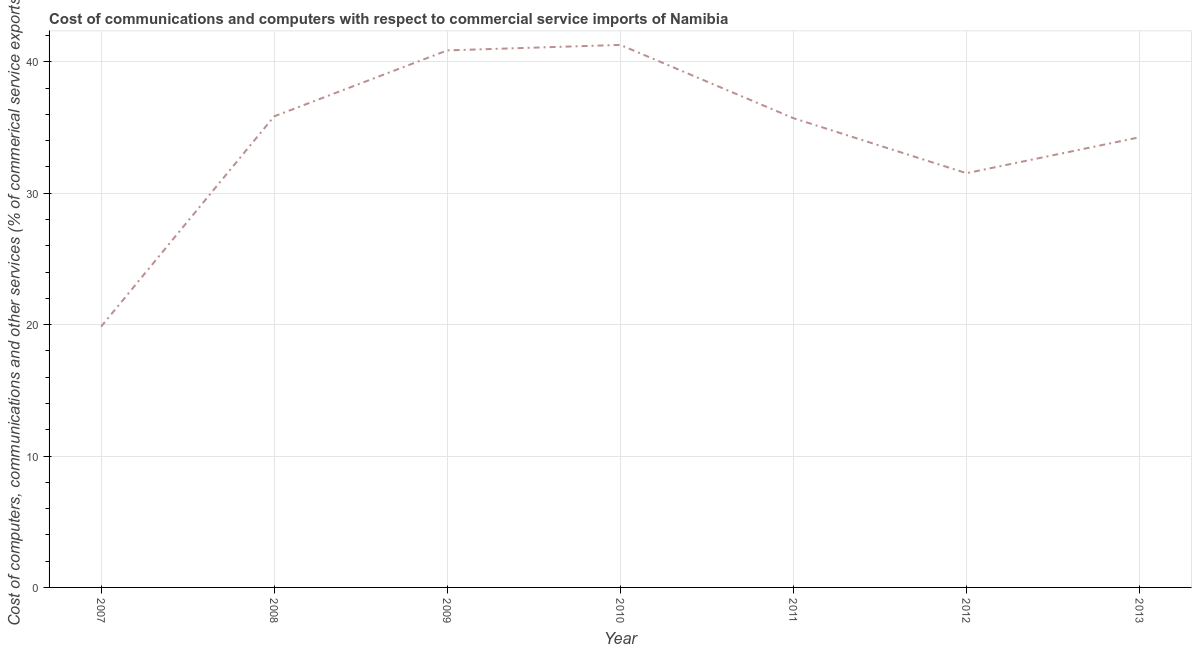What is the  computer and other services in 2013?
Offer a terse response. 34.26. Across all years, what is the maximum  computer and other services?
Provide a succinct answer. 41.28. Across all years, what is the minimum cost of communications?
Your response must be concise. 19.84. In which year was the cost of communications maximum?
Provide a succinct answer. 2010. What is the sum of the cost of communications?
Provide a short and direct response. 239.32. What is the difference between the  computer and other services in 2007 and 2008?
Keep it short and to the point. -16. What is the average cost of communications per year?
Provide a short and direct response. 34.19. What is the median  computer and other services?
Your answer should be compact. 35.71. In how many years, is the  computer and other services greater than 4 %?
Your response must be concise. 7. What is the ratio of the  computer and other services in 2012 to that in 2013?
Provide a short and direct response. 0.92. Is the difference between the cost of communications in 2008 and 2010 greater than the difference between any two years?
Your response must be concise. No. What is the difference between the highest and the second highest cost of communications?
Your response must be concise. 0.42. Is the sum of the cost of communications in 2010 and 2011 greater than the maximum cost of communications across all years?
Offer a terse response. Yes. What is the difference between the highest and the lowest cost of communications?
Provide a succinct answer. 21.44. Does the cost of communications monotonically increase over the years?
Your response must be concise. No. What is the difference between two consecutive major ticks on the Y-axis?
Make the answer very short. 10. Are the values on the major ticks of Y-axis written in scientific E-notation?
Keep it short and to the point. No. Does the graph contain any zero values?
Ensure brevity in your answer.  No. Does the graph contain grids?
Provide a succinct answer. Yes. What is the title of the graph?
Make the answer very short. Cost of communications and computers with respect to commercial service imports of Namibia. What is the label or title of the Y-axis?
Make the answer very short. Cost of computers, communications and other services (% of commerical service exports). What is the Cost of computers, communications and other services (% of commerical service exports) of 2007?
Provide a short and direct response. 19.84. What is the Cost of computers, communications and other services (% of commerical service exports) in 2008?
Make the answer very short. 35.85. What is the Cost of computers, communications and other services (% of commerical service exports) in 2009?
Offer a terse response. 40.87. What is the Cost of computers, communications and other services (% of commerical service exports) of 2010?
Offer a very short reply. 41.28. What is the Cost of computers, communications and other services (% of commerical service exports) of 2011?
Ensure brevity in your answer.  35.71. What is the Cost of computers, communications and other services (% of commerical service exports) of 2012?
Your answer should be very brief. 31.52. What is the Cost of computers, communications and other services (% of commerical service exports) of 2013?
Keep it short and to the point. 34.26. What is the difference between the Cost of computers, communications and other services (% of commerical service exports) in 2007 and 2008?
Your answer should be very brief. -16. What is the difference between the Cost of computers, communications and other services (% of commerical service exports) in 2007 and 2009?
Provide a succinct answer. -21.02. What is the difference between the Cost of computers, communications and other services (% of commerical service exports) in 2007 and 2010?
Make the answer very short. -21.44. What is the difference between the Cost of computers, communications and other services (% of commerical service exports) in 2007 and 2011?
Provide a succinct answer. -15.86. What is the difference between the Cost of computers, communications and other services (% of commerical service exports) in 2007 and 2012?
Your response must be concise. -11.68. What is the difference between the Cost of computers, communications and other services (% of commerical service exports) in 2007 and 2013?
Ensure brevity in your answer.  -14.41. What is the difference between the Cost of computers, communications and other services (% of commerical service exports) in 2008 and 2009?
Provide a short and direct response. -5.02. What is the difference between the Cost of computers, communications and other services (% of commerical service exports) in 2008 and 2010?
Your answer should be compact. -5.44. What is the difference between the Cost of computers, communications and other services (% of commerical service exports) in 2008 and 2011?
Offer a very short reply. 0.14. What is the difference between the Cost of computers, communications and other services (% of commerical service exports) in 2008 and 2012?
Offer a terse response. 4.33. What is the difference between the Cost of computers, communications and other services (% of commerical service exports) in 2008 and 2013?
Ensure brevity in your answer.  1.59. What is the difference between the Cost of computers, communications and other services (% of commerical service exports) in 2009 and 2010?
Offer a very short reply. -0.42. What is the difference between the Cost of computers, communications and other services (% of commerical service exports) in 2009 and 2011?
Offer a terse response. 5.16. What is the difference between the Cost of computers, communications and other services (% of commerical service exports) in 2009 and 2012?
Keep it short and to the point. 9.35. What is the difference between the Cost of computers, communications and other services (% of commerical service exports) in 2009 and 2013?
Keep it short and to the point. 6.61. What is the difference between the Cost of computers, communications and other services (% of commerical service exports) in 2010 and 2011?
Your answer should be compact. 5.57. What is the difference between the Cost of computers, communications and other services (% of commerical service exports) in 2010 and 2012?
Offer a very short reply. 9.76. What is the difference between the Cost of computers, communications and other services (% of commerical service exports) in 2010 and 2013?
Make the answer very short. 7.03. What is the difference between the Cost of computers, communications and other services (% of commerical service exports) in 2011 and 2012?
Your answer should be compact. 4.19. What is the difference between the Cost of computers, communications and other services (% of commerical service exports) in 2011 and 2013?
Offer a very short reply. 1.45. What is the difference between the Cost of computers, communications and other services (% of commerical service exports) in 2012 and 2013?
Provide a succinct answer. -2.74. What is the ratio of the Cost of computers, communications and other services (% of commerical service exports) in 2007 to that in 2008?
Make the answer very short. 0.55. What is the ratio of the Cost of computers, communications and other services (% of commerical service exports) in 2007 to that in 2009?
Ensure brevity in your answer.  0.49. What is the ratio of the Cost of computers, communications and other services (% of commerical service exports) in 2007 to that in 2010?
Make the answer very short. 0.48. What is the ratio of the Cost of computers, communications and other services (% of commerical service exports) in 2007 to that in 2011?
Your answer should be compact. 0.56. What is the ratio of the Cost of computers, communications and other services (% of commerical service exports) in 2007 to that in 2012?
Your answer should be very brief. 0.63. What is the ratio of the Cost of computers, communications and other services (% of commerical service exports) in 2007 to that in 2013?
Offer a terse response. 0.58. What is the ratio of the Cost of computers, communications and other services (% of commerical service exports) in 2008 to that in 2009?
Offer a terse response. 0.88. What is the ratio of the Cost of computers, communications and other services (% of commerical service exports) in 2008 to that in 2010?
Give a very brief answer. 0.87. What is the ratio of the Cost of computers, communications and other services (% of commerical service exports) in 2008 to that in 2011?
Provide a short and direct response. 1. What is the ratio of the Cost of computers, communications and other services (% of commerical service exports) in 2008 to that in 2012?
Give a very brief answer. 1.14. What is the ratio of the Cost of computers, communications and other services (% of commerical service exports) in 2008 to that in 2013?
Offer a very short reply. 1.05. What is the ratio of the Cost of computers, communications and other services (% of commerical service exports) in 2009 to that in 2011?
Offer a very short reply. 1.14. What is the ratio of the Cost of computers, communications and other services (% of commerical service exports) in 2009 to that in 2012?
Make the answer very short. 1.3. What is the ratio of the Cost of computers, communications and other services (% of commerical service exports) in 2009 to that in 2013?
Offer a terse response. 1.19. What is the ratio of the Cost of computers, communications and other services (% of commerical service exports) in 2010 to that in 2011?
Your answer should be very brief. 1.16. What is the ratio of the Cost of computers, communications and other services (% of commerical service exports) in 2010 to that in 2012?
Offer a very short reply. 1.31. What is the ratio of the Cost of computers, communications and other services (% of commerical service exports) in 2010 to that in 2013?
Your answer should be compact. 1.21. What is the ratio of the Cost of computers, communications and other services (% of commerical service exports) in 2011 to that in 2012?
Ensure brevity in your answer.  1.13. What is the ratio of the Cost of computers, communications and other services (% of commerical service exports) in 2011 to that in 2013?
Your answer should be compact. 1.04. 